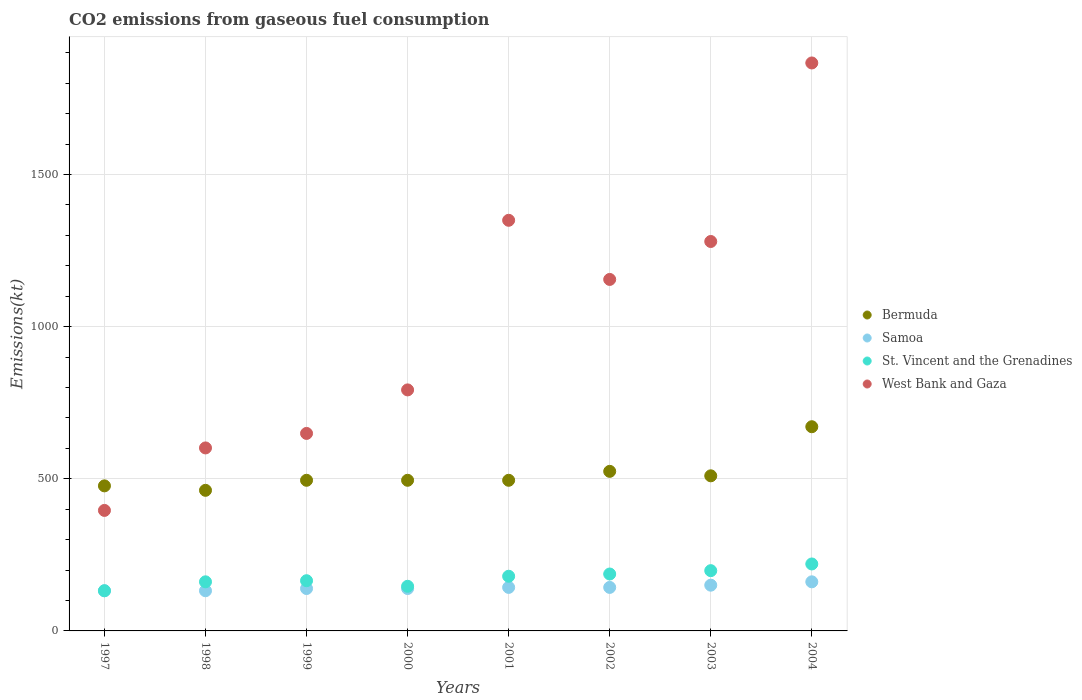How many different coloured dotlines are there?
Keep it short and to the point. 4. What is the amount of CO2 emitted in Bermuda in 1997?
Your answer should be compact. 476.71. Across all years, what is the maximum amount of CO2 emitted in Bermuda?
Your answer should be very brief. 671.06. Across all years, what is the minimum amount of CO2 emitted in Samoa?
Make the answer very short. 132.01. What is the total amount of CO2 emitted in St. Vincent and the Grenadines in the graph?
Ensure brevity in your answer.  1389.79. What is the difference between the amount of CO2 emitted in Bermuda in 1997 and that in 2001?
Make the answer very short. -18.34. What is the difference between the amount of CO2 emitted in Samoa in 2002 and the amount of CO2 emitted in West Bank and Gaza in 1997?
Your answer should be very brief. -253.02. What is the average amount of CO2 emitted in St. Vincent and the Grenadines per year?
Keep it short and to the point. 173.72. In the year 1999, what is the difference between the amount of CO2 emitted in Samoa and amount of CO2 emitted in West Bank and Gaza?
Make the answer very short. -509.71. In how many years, is the amount of CO2 emitted in Bermuda greater than 1600 kt?
Provide a succinct answer. 0. What is the ratio of the amount of CO2 emitted in West Bank and Gaza in 2001 to that in 2003?
Your answer should be very brief. 1.05. Is the amount of CO2 emitted in West Bank and Gaza in 2001 less than that in 2002?
Keep it short and to the point. No. What is the difference between the highest and the second highest amount of CO2 emitted in Samoa?
Offer a terse response. 11. What is the difference between the highest and the lowest amount of CO2 emitted in Samoa?
Provide a short and direct response. 29.34. In how many years, is the amount of CO2 emitted in West Bank and Gaza greater than the average amount of CO2 emitted in West Bank and Gaza taken over all years?
Offer a terse response. 4. Is it the case that in every year, the sum of the amount of CO2 emitted in Bermuda and amount of CO2 emitted in West Bank and Gaza  is greater than the sum of amount of CO2 emitted in Samoa and amount of CO2 emitted in St. Vincent and the Grenadines?
Provide a succinct answer. No. Does the amount of CO2 emitted in West Bank and Gaza monotonically increase over the years?
Make the answer very short. No. Is the amount of CO2 emitted in St. Vincent and the Grenadines strictly less than the amount of CO2 emitted in West Bank and Gaza over the years?
Provide a short and direct response. Yes. How many dotlines are there?
Keep it short and to the point. 4. How many years are there in the graph?
Ensure brevity in your answer.  8. How are the legend labels stacked?
Give a very brief answer. Vertical. What is the title of the graph?
Keep it short and to the point. CO2 emissions from gaseous fuel consumption. What is the label or title of the X-axis?
Your answer should be compact. Years. What is the label or title of the Y-axis?
Ensure brevity in your answer.  Emissions(kt). What is the Emissions(kt) in Bermuda in 1997?
Make the answer very short. 476.71. What is the Emissions(kt) of Samoa in 1997?
Give a very brief answer. 132.01. What is the Emissions(kt) of St. Vincent and the Grenadines in 1997?
Your answer should be very brief. 132.01. What is the Emissions(kt) in West Bank and Gaza in 1997?
Offer a very short reply. 396.04. What is the Emissions(kt) in Bermuda in 1998?
Give a very brief answer. 462.04. What is the Emissions(kt) of Samoa in 1998?
Your answer should be compact. 132.01. What is the Emissions(kt) of St. Vincent and the Grenadines in 1998?
Keep it short and to the point. 161.35. What is the Emissions(kt) of West Bank and Gaza in 1998?
Provide a short and direct response. 601.39. What is the Emissions(kt) of Bermuda in 1999?
Provide a short and direct response. 495.05. What is the Emissions(kt) of Samoa in 1999?
Offer a very short reply. 139.35. What is the Emissions(kt) in St. Vincent and the Grenadines in 1999?
Offer a terse response. 165.01. What is the Emissions(kt) in West Bank and Gaza in 1999?
Offer a terse response. 649.06. What is the Emissions(kt) in Bermuda in 2000?
Ensure brevity in your answer.  495.05. What is the Emissions(kt) of Samoa in 2000?
Your response must be concise. 139.35. What is the Emissions(kt) in St. Vincent and the Grenadines in 2000?
Give a very brief answer. 146.68. What is the Emissions(kt) in West Bank and Gaza in 2000?
Your answer should be compact. 792.07. What is the Emissions(kt) of Bermuda in 2001?
Ensure brevity in your answer.  495.05. What is the Emissions(kt) of Samoa in 2001?
Your answer should be very brief. 143.01. What is the Emissions(kt) of St. Vincent and the Grenadines in 2001?
Keep it short and to the point. 179.68. What is the Emissions(kt) in West Bank and Gaza in 2001?
Ensure brevity in your answer.  1349.46. What is the Emissions(kt) of Bermuda in 2002?
Provide a succinct answer. 524.38. What is the Emissions(kt) of Samoa in 2002?
Provide a succinct answer. 143.01. What is the Emissions(kt) in St. Vincent and the Grenadines in 2002?
Give a very brief answer. 187.02. What is the Emissions(kt) in West Bank and Gaza in 2002?
Make the answer very short. 1155.11. What is the Emissions(kt) in Bermuda in 2003?
Your response must be concise. 509.71. What is the Emissions(kt) of Samoa in 2003?
Offer a terse response. 150.35. What is the Emissions(kt) of St. Vincent and the Grenadines in 2003?
Provide a succinct answer. 198.02. What is the Emissions(kt) of West Bank and Gaza in 2003?
Your answer should be very brief. 1279.78. What is the Emissions(kt) of Bermuda in 2004?
Offer a very short reply. 671.06. What is the Emissions(kt) of Samoa in 2004?
Offer a very short reply. 161.35. What is the Emissions(kt) in St. Vincent and the Grenadines in 2004?
Provide a succinct answer. 220.02. What is the Emissions(kt) of West Bank and Gaza in 2004?
Offer a terse response. 1866.5. Across all years, what is the maximum Emissions(kt) in Bermuda?
Offer a terse response. 671.06. Across all years, what is the maximum Emissions(kt) of Samoa?
Provide a short and direct response. 161.35. Across all years, what is the maximum Emissions(kt) in St. Vincent and the Grenadines?
Ensure brevity in your answer.  220.02. Across all years, what is the maximum Emissions(kt) of West Bank and Gaza?
Offer a terse response. 1866.5. Across all years, what is the minimum Emissions(kt) in Bermuda?
Give a very brief answer. 462.04. Across all years, what is the minimum Emissions(kt) in Samoa?
Your response must be concise. 132.01. Across all years, what is the minimum Emissions(kt) in St. Vincent and the Grenadines?
Your response must be concise. 132.01. Across all years, what is the minimum Emissions(kt) in West Bank and Gaza?
Your answer should be very brief. 396.04. What is the total Emissions(kt) of Bermuda in the graph?
Your answer should be compact. 4129.04. What is the total Emissions(kt) in Samoa in the graph?
Your response must be concise. 1140.44. What is the total Emissions(kt) of St. Vincent and the Grenadines in the graph?
Provide a succinct answer. 1389.79. What is the total Emissions(kt) of West Bank and Gaza in the graph?
Your answer should be compact. 8089.4. What is the difference between the Emissions(kt) in Bermuda in 1997 and that in 1998?
Ensure brevity in your answer.  14.67. What is the difference between the Emissions(kt) of St. Vincent and the Grenadines in 1997 and that in 1998?
Make the answer very short. -29.34. What is the difference between the Emissions(kt) in West Bank and Gaza in 1997 and that in 1998?
Give a very brief answer. -205.35. What is the difference between the Emissions(kt) of Bermuda in 1997 and that in 1999?
Offer a very short reply. -18.34. What is the difference between the Emissions(kt) of Samoa in 1997 and that in 1999?
Offer a very short reply. -7.33. What is the difference between the Emissions(kt) in St. Vincent and the Grenadines in 1997 and that in 1999?
Provide a short and direct response. -33. What is the difference between the Emissions(kt) of West Bank and Gaza in 1997 and that in 1999?
Your answer should be compact. -253.02. What is the difference between the Emissions(kt) in Bermuda in 1997 and that in 2000?
Offer a terse response. -18.34. What is the difference between the Emissions(kt) in Samoa in 1997 and that in 2000?
Offer a very short reply. -7.33. What is the difference between the Emissions(kt) of St. Vincent and the Grenadines in 1997 and that in 2000?
Offer a very short reply. -14.67. What is the difference between the Emissions(kt) in West Bank and Gaza in 1997 and that in 2000?
Provide a succinct answer. -396.04. What is the difference between the Emissions(kt) in Bermuda in 1997 and that in 2001?
Make the answer very short. -18.34. What is the difference between the Emissions(kt) of Samoa in 1997 and that in 2001?
Give a very brief answer. -11. What is the difference between the Emissions(kt) of St. Vincent and the Grenadines in 1997 and that in 2001?
Make the answer very short. -47.67. What is the difference between the Emissions(kt) in West Bank and Gaza in 1997 and that in 2001?
Your answer should be compact. -953.42. What is the difference between the Emissions(kt) of Bermuda in 1997 and that in 2002?
Provide a succinct answer. -47.67. What is the difference between the Emissions(kt) in Samoa in 1997 and that in 2002?
Your answer should be very brief. -11. What is the difference between the Emissions(kt) in St. Vincent and the Grenadines in 1997 and that in 2002?
Provide a succinct answer. -55.01. What is the difference between the Emissions(kt) of West Bank and Gaza in 1997 and that in 2002?
Offer a very short reply. -759.07. What is the difference between the Emissions(kt) of Bermuda in 1997 and that in 2003?
Keep it short and to the point. -33. What is the difference between the Emissions(kt) in Samoa in 1997 and that in 2003?
Make the answer very short. -18.34. What is the difference between the Emissions(kt) in St. Vincent and the Grenadines in 1997 and that in 2003?
Provide a succinct answer. -66.01. What is the difference between the Emissions(kt) of West Bank and Gaza in 1997 and that in 2003?
Give a very brief answer. -883.75. What is the difference between the Emissions(kt) in Bermuda in 1997 and that in 2004?
Keep it short and to the point. -194.35. What is the difference between the Emissions(kt) of Samoa in 1997 and that in 2004?
Your answer should be very brief. -29.34. What is the difference between the Emissions(kt) in St. Vincent and the Grenadines in 1997 and that in 2004?
Keep it short and to the point. -88.01. What is the difference between the Emissions(kt) in West Bank and Gaza in 1997 and that in 2004?
Provide a short and direct response. -1470.47. What is the difference between the Emissions(kt) in Bermuda in 1998 and that in 1999?
Keep it short and to the point. -33. What is the difference between the Emissions(kt) in Samoa in 1998 and that in 1999?
Provide a short and direct response. -7.33. What is the difference between the Emissions(kt) of St. Vincent and the Grenadines in 1998 and that in 1999?
Keep it short and to the point. -3.67. What is the difference between the Emissions(kt) of West Bank and Gaza in 1998 and that in 1999?
Your answer should be very brief. -47.67. What is the difference between the Emissions(kt) in Bermuda in 1998 and that in 2000?
Give a very brief answer. -33. What is the difference between the Emissions(kt) in Samoa in 1998 and that in 2000?
Your response must be concise. -7.33. What is the difference between the Emissions(kt) in St. Vincent and the Grenadines in 1998 and that in 2000?
Offer a terse response. 14.67. What is the difference between the Emissions(kt) in West Bank and Gaza in 1998 and that in 2000?
Make the answer very short. -190.68. What is the difference between the Emissions(kt) of Bermuda in 1998 and that in 2001?
Your answer should be very brief. -33. What is the difference between the Emissions(kt) of Samoa in 1998 and that in 2001?
Ensure brevity in your answer.  -11. What is the difference between the Emissions(kt) of St. Vincent and the Grenadines in 1998 and that in 2001?
Your response must be concise. -18.34. What is the difference between the Emissions(kt) in West Bank and Gaza in 1998 and that in 2001?
Your answer should be very brief. -748.07. What is the difference between the Emissions(kt) of Bermuda in 1998 and that in 2002?
Provide a short and direct response. -62.34. What is the difference between the Emissions(kt) of Samoa in 1998 and that in 2002?
Make the answer very short. -11. What is the difference between the Emissions(kt) in St. Vincent and the Grenadines in 1998 and that in 2002?
Keep it short and to the point. -25.67. What is the difference between the Emissions(kt) in West Bank and Gaza in 1998 and that in 2002?
Your answer should be very brief. -553.72. What is the difference between the Emissions(kt) in Bermuda in 1998 and that in 2003?
Offer a terse response. -47.67. What is the difference between the Emissions(kt) in Samoa in 1998 and that in 2003?
Your answer should be compact. -18.34. What is the difference between the Emissions(kt) in St. Vincent and the Grenadines in 1998 and that in 2003?
Your answer should be very brief. -36.67. What is the difference between the Emissions(kt) of West Bank and Gaza in 1998 and that in 2003?
Your response must be concise. -678.39. What is the difference between the Emissions(kt) in Bermuda in 1998 and that in 2004?
Your response must be concise. -209.02. What is the difference between the Emissions(kt) of Samoa in 1998 and that in 2004?
Make the answer very short. -29.34. What is the difference between the Emissions(kt) of St. Vincent and the Grenadines in 1998 and that in 2004?
Your answer should be very brief. -58.67. What is the difference between the Emissions(kt) in West Bank and Gaza in 1998 and that in 2004?
Your response must be concise. -1265.12. What is the difference between the Emissions(kt) in Samoa in 1999 and that in 2000?
Provide a short and direct response. 0. What is the difference between the Emissions(kt) in St. Vincent and the Grenadines in 1999 and that in 2000?
Provide a short and direct response. 18.34. What is the difference between the Emissions(kt) of West Bank and Gaza in 1999 and that in 2000?
Offer a terse response. -143.01. What is the difference between the Emissions(kt) of Samoa in 1999 and that in 2001?
Make the answer very short. -3.67. What is the difference between the Emissions(kt) in St. Vincent and the Grenadines in 1999 and that in 2001?
Offer a very short reply. -14.67. What is the difference between the Emissions(kt) of West Bank and Gaza in 1999 and that in 2001?
Offer a terse response. -700.4. What is the difference between the Emissions(kt) of Bermuda in 1999 and that in 2002?
Ensure brevity in your answer.  -29.34. What is the difference between the Emissions(kt) of Samoa in 1999 and that in 2002?
Keep it short and to the point. -3.67. What is the difference between the Emissions(kt) of St. Vincent and the Grenadines in 1999 and that in 2002?
Keep it short and to the point. -22. What is the difference between the Emissions(kt) of West Bank and Gaza in 1999 and that in 2002?
Make the answer very short. -506.05. What is the difference between the Emissions(kt) in Bermuda in 1999 and that in 2003?
Offer a very short reply. -14.67. What is the difference between the Emissions(kt) in Samoa in 1999 and that in 2003?
Offer a terse response. -11. What is the difference between the Emissions(kt) of St. Vincent and the Grenadines in 1999 and that in 2003?
Your answer should be compact. -33. What is the difference between the Emissions(kt) in West Bank and Gaza in 1999 and that in 2003?
Provide a succinct answer. -630.72. What is the difference between the Emissions(kt) of Bermuda in 1999 and that in 2004?
Make the answer very short. -176.02. What is the difference between the Emissions(kt) in Samoa in 1999 and that in 2004?
Your response must be concise. -22. What is the difference between the Emissions(kt) of St. Vincent and the Grenadines in 1999 and that in 2004?
Provide a short and direct response. -55.01. What is the difference between the Emissions(kt) in West Bank and Gaza in 1999 and that in 2004?
Offer a terse response. -1217.44. What is the difference between the Emissions(kt) of Samoa in 2000 and that in 2001?
Your response must be concise. -3.67. What is the difference between the Emissions(kt) in St. Vincent and the Grenadines in 2000 and that in 2001?
Keep it short and to the point. -33. What is the difference between the Emissions(kt) of West Bank and Gaza in 2000 and that in 2001?
Keep it short and to the point. -557.38. What is the difference between the Emissions(kt) of Bermuda in 2000 and that in 2002?
Your response must be concise. -29.34. What is the difference between the Emissions(kt) of Samoa in 2000 and that in 2002?
Keep it short and to the point. -3.67. What is the difference between the Emissions(kt) of St. Vincent and the Grenadines in 2000 and that in 2002?
Give a very brief answer. -40.34. What is the difference between the Emissions(kt) in West Bank and Gaza in 2000 and that in 2002?
Give a very brief answer. -363.03. What is the difference between the Emissions(kt) in Bermuda in 2000 and that in 2003?
Offer a terse response. -14.67. What is the difference between the Emissions(kt) in Samoa in 2000 and that in 2003?
Offer a very short reply. -11. What is the difference between the Emissions(kt) in St. Vincent and the Grenadines in 2000 and that in 2003?
Your answer should be compact. -51.34. What is the difference between the Emissions(kt) of West Bank and Gaza in 2000 and that in 2003?
Keep it short and to the point. -487.71. What is the difference between the Emissions(kt) of Bermuda in 2000 and that in 2004?
Keep it short and to the point. -176.02. What is the difference between the Emissions(kt) in Samoa in 2000 and that in 2004?
Provide a succinct answer. -22. What is the difference between the Emissions(kt) of St. Vincent and the Grenadines in 2000 and that in 2004?
Make the answer very short. -73.34. What is the difference between the Emissions(kt) in West Bank and Gaza in 2000 and that in 2004?
Offer a terse response. -1074.43. What is the difference between the Emissions(kt) of Bermuda in 2001 and that in 2002?
Ensure brevity in your answer.  -29.34. What is the difference between the Emissions(kt) in Samoa in 2001 and that in 2002?
Provide a succinct answer. 0. What is the difference between the Emissions(kt) of St. Vincent and the Grenadines in 2001 and that in 2002?
Your response must be concise. -7.33. What is the difference between the Emissions(kt) in West Bank and Gaza in 2001 and that in 2002?
Your response must be concise. 194.35. What is the difference between the Emissions(kt) of Bermuda in 2001 and that in 2003?
Ensure brevity in your answer.  -14.67. What is the difference between the Emissions(kt) in Samoa in 2001 and that in 2003?
Your response must be concise. -7.33. What is the difference between the Emissions(kt) in St. Vincent and the Grenadines in 2001 and that in 2003?
Your answer should be compact. -18.34. What is the difference between the Emissions(kt) of West Bank and Gaza in 2001 and that in 2003?
Give a very brief answer. 69.67. What is the difference between the Emissions(kt) of Bermuda in 2001 and that in 2004?
Your answer should be very brief. -176.02. What is the difference between the Emissions(kt) in Samoa in 2001 and that in 2004?
Provide a short and direct response. -18.34. What is the difference between the Emissions(kt) of St. Vincent and the Grenadines in 2001 and that in 2004?
Offer a very short reply. -40.34. What is the difference between the Emissions(kt) of West Bank and Gaza in 2001 and that in 2004?
Offer a very short reply. -517.05. What is the difference between the Emissions(kt) of Bermuda in 2002 and that in 2003?
Make the answer very short. 14.67. What is the difference between the Emissions(kt) in Samoa in 2002 and that in 2003?
Your response must be concise. -7.33. What is the difference between the Emissions(kt) of St. Vincent and the Grenadines in 2002 and that in 2003?
Offer a terse response. -11. What is the difference between the Emissions(kt) in West Bank and Gaza in 2002 and that in 2003?
Keep it short and to the point. -124.68. What is the difference between the Emissions(kt) of Bermuda in 2002 and that in 2004?
Provide a succinct answer. -146.68. What is the difference between the Emissions(kt) in Samoa in 2002 and that in 2004?
Your response must be concise. -18.34. What is the difference between the Emissions(kt) of St. Vincent and the Grenadines in 2002 and that in 2004?
Your answer should be compact. -33. What is the difference between the Emissions(kt) in West Bank and Gaza in 2002 and that in 2004?
Provide a short and direct response. -711.4. What is the difference between the Emissions(kt) of Bermuda in 2003 and that in 2004?
Keep it short and to the point. -161.35. What is the difference between the Emissions(kt) in Samoa in 2003 and that in 2004?
Keep it short and to the point. -11. What is the difference between the Emissions(kt) in St. Vincent and the Grenadines in 2003 and that in 2004?
Ensure brevity in your answer.  -22. What is the difference between the Emissions(kt) of West Bank and Gaza in 2003 and that in 2004?
Your response must be concise. -586.72. What is the difference between the Emissions(kt) in Bermuda in 1997 and the Emissions(kt) in Samoa in 1998?
Your answer should be very brief. 344.7. What is the difference between the Emissions(kt) in Bermuda in 1997 and the Emissions(kt) in St. Vincent and the Grenadines in 1998?
Provide a succinct answer. 315.36. What is the difference between the Emissions(kt) of Bermuda in 1997 and the Emissions(kt) of West Bank and Gaza in 1998?
Provide a short and direct response. -124.68. What is the difference between the Emissions(kt) of Samoa in 1997 and the Emissions(kt) of St. Vincent and the Grenadines in 1998?
Give a very brief answer. -29.34. What is the difference between the Emissions(kt) in Samoa in 1997 and the Emissions(kt) in West Bank and Gaza in 1998?
Offer a terse response. -469.38. What is the difference between the Emissions(kt) in St. Vincent and the Grenadines in 1997 and the Emissions(kt) in West Bank and Gaza in 1998?
Your response must be concise. -469.38. What is the difference between the Emissions(kt) in Bermuda in 1997 and the Emissions(kt) in Samoa in 1999?
Provide a succinct answer. 337.36. What is the difference between the Emissions(kt) in Bermuda in 1997 and the Emissions(kt) in St. Vincent and the Grenadines in 1999?
Make the answer very short. 311.69. What is the difference between the Emissions(kt) in Bermuda in 1997 and the Emissions(kt) in West Bank and Gaza in 1999?
Offer a very short reply. -172.35. What is the difference between the Emissions(kt) of Samoa in 1997 and the Emissions(kt) of St. Vincent and the Grenadines in 1999?
Provide a succinct answer. -33. What is the difference between the Emissions(kt) in Samoa in 1997 and the Emissions(kt) in West Bank and Gaza in 1999?
Your answer should be very brief. -517.05. What is the difference between the Emissions(kt) of St. Vincent and the Grenadines in 1997 and the Emissions(kt) of West Bank and Gaza in 1999?
Provide a short and direct response. -517.05. What is the difference between the Emissions(kt) in Bermuda in 1997 and the Emissions(kt) in Samoa in 2000?
Your answer should be compact. 337.36. What is the difference between the Emissions(kt) in Bermuda in 1997 and the Emissions(kt) in St. Vincent and the Grenadines in 2000?
Your answer should be very brief. 330.03. What is the difference between the Emissions(kt) in Bermuda in 1997 and the Emissions(kt) in West Bank and Gaza in 2000?
Your response must be concise. -315.36. What is the difference between the Emissions(kt) of Samoa in 1997 and the Emissions(kt) of St. Vincent and the Grenadines in 2000?
Your response must be concise. -14.67. What is the difference between the Emissions(kt) of Samoa in 1997 and the Emissions(kt) of West Bank and Gaza in 2000?
Your answer should be compact. -660.06. What is the difference between the Emissions(kt) of St. Vincent and the Grenadines in 1997 and the Emissions(kt) of West Bank and Gaza in 2000?
Your response must be concise. -660.06. What is the difference between the Emissions(kt) of Bermuda in 1997 and the Emissions(kt) of Samoa in 2001?
Your answer should be compact. 333.7. What is the difference between the Emissions(kt) of Bermuda in 1997 and the Emissions(kt) of St. Vincent and the Grenadines in 2001?
Your response must be concise. 297.03. What is the difference between the Emissions(kt) of Bermuda in 1997 and the Emissions(kt) of West Bank and Gaza in 2001?
Provide a short and direct response. -872.75. What is the difference between the Emissions(kt) of Samoa in 1997 and the Emissions(kt) of St. Vincent and the Grenadines in 2001?
Provide a succinct answer. -47.67. What is the difference between the Emissions(kt) in Samoa in 1997 and the Emissions(kt) in West Bank and Gaza in 2001?
Ensure brevity in your answer.  -1217.44. What is the difference between the Emissions(kt) of St. Vincent and the Grenadines in 1997 and the Emissions(kt) of West Bank and Gaza in 2001?
Give a very brief answer. -1217.44. What is the difference between the Emissions(kt) of Bermuda in 1997 and the Emissions(kt) of Samoa in 2002?
Provide a short and direct response. 333.7. What is the difference between the Emissions(kt) of Bermuda in 1997 and the Emissions(kt) of St. Vincent and the Grenadines in 2002?
Make the answer very short. 289.69. What is the difference between the Emissions(kt) in Bermuda in 1997 and the Emissions(kt) in West Bank and Gaza in 2002?
Your answer should be compact. -678.39. What is the difference between the Emissions(kt) of Samoa in 1997 and the Emissions(kt) of St. Vincent and the Grenadines in 2002?
Provide a short and direct response. -55.01. What is the difference between the Emissions(kt) of Samoa in 1997 and the Emissions(kt) of West Bank and Gaza in 2002?
Your answer should be very brief. -1023.09. What is the difference between the Emissions(kt) of St. Vincent and the Grenadines in 1997 and the Emissions(kt) of West Bank and Gaza in 2002?
Your answer should be very brief. -1023.09. What is the difference between the Emissions(kt) in Bermuda in 1997 and the Emissions(kt) in Samoa in 2003?
Your answer should be very brief. 326.36. What is the difference between the Emissions(kt) in Bermuda in 1997 and the Emissions(kt) in St. Vincent and the Grenadines in 2003?
Your answer should be compact. 278.69. What is the difference between the Emissions(kt) in Bermuda in 1997 and the Emissions(kt) in West Bank and Gaza in 2003?
Your answer should be compact. -803.07. What is the difference between the Emissions(kt) of Samoa in 1997 and the Emissions(kt) of St. Vincent and the Grenadines in 2003?
Offer a very short reply. -66.01. What is the difference between the Emissions(kt) in Samoa in 1997 and the Emissions(kt) in West Bank and Gaza in 2003?
Ensure brevity in your answer.  -1147.77. What is the difference between the Emissions(kt) in St. Vincent and the Grenadines in 1997 and the Emissions(kt) in West Bank and Gaza in 2003?
Ensure brevity in your answer.  -1147.77. What is the difference between the Emissions(kt) of Bermuda in 1997 and the Emissions(kt) of Samoa in 2004?
Make the answer very short. 315.36. What is the difference between the Emissions(kt) in Bermuda in 1997 and the Emissions(kt) in St. Vincent and the Grenadines in 2004?
Your answer should be compact. 256.69. What is the difference between the Emissions(kt) in Bermuda in 1997 and the Emissions(kt) in West Bank and Gaza in 2004?
Provide a short and direct response. -1389.79. What is the difference between the Emissions(kt) of Samoa in 1997 and the Emissions(kt) of St. Vincent and the Grenadines in 2004?
Give a very brief answer. -88.01. What is the difference between the Emissions(kt) of Samoa in 1997 and the Emissions(kt) of West Bank and Gaza in 2004?
Keep it short and to the point. -1734.49. What is the difference between the Emissions(kt) in St. Vincent and the Grenadines in 1997 and the Emissions(kt) in West Bank and Gaza in 2004?
Your answer should be very brief. -1734.49. What is the difference between the Emissions(kt) in Bermuda in 1998 and the Emissions(kt) in Samoa in 1999?
Provide a succinct answer. 322.7. What is the difference between the Emissions(kt) in Bermuda in 1998 and the Emissions(kt) in St. Vincent and the Grenadines in 1999?
Your response must be concise. 297.03. What is the difference between the Emissions(kt) of Bermuda in 1998 and the Emissions(kt) of West Bank and Gaza in 1999?
Keep it short and to the point. -187.02. What is the difference between the Emissions(kt) of Samoa in 1998 and the Emissions(kt) of St. Vincent and the Grenadines in 1999?
Ensure brevity in your answer.  -33. What is the difference between the Emissions(kt) of Samoa in 1998 and the Emissions(kt) of West Bank and Gaza in 1999?
Provide a succinct answer. -517.05. What is the difference between the Emissions(kt) of St. Vincent and the Grenadines in 1998 and the Emissions(kt) of West Bank and Gaza in 1999?
Your response must be concise. -487.71. What is the difference between the Emissions(kt) of Bermuda in 1998 and the Emissions(kt) of Samoa in 2000?
Provide a succinct answer. 322.7. What is the difference between the Emissions(kt) of Bermuda in 1998 and the Emissions(kt) of St. Vincent and the Grenadines in 2000?
Ensure brevity in your answer.  315.36. What is the difference between the Emissions(kt) of Bermuda in 1998 and the Emissions(kt) of West Bank and Gaza in 2000?
Make the answer very short. -330.03. What is the difference between the Emissions(kt) in Samoa in 1998 and the Emissions(kt) in St. Vincent and the Grenadines in 2000?
Your answer should be very brief. -14.67. What is the difference between the Emissions(kt) of Samoa in 1998 and the Emissions(kt) of West Bank and Gaza in 2000?
Provide a short and direct response. -660.06. What is the difference between the Emissions(kt) of St. Vincent and the Grenadines in 1998 and the Emissions(kt) of West Bank and Gaza in 2000?
Make the answer very short. -630.72. What is the difference between the Emissions(kt) in Bermuda in 1998 and the Emissions(kt) in Samoa in 2001?
Ensure brevity in your answer.  319.03. What is the difference between the Emissions(kt) in Bermuda in 1998 and the Emissions(kt) in St. Vincent and the Grenadines in 2001?
Your answer should be compact. 282.36. What is the difference between the Emissions(kt) in Bermuda in 1998 and the Emissions(kt) in West Bank and Gaza in 2001?
Ensure brevity in your answer.  -887.41. What is the difference between the Emissions(kt) in Samoa in 1998 and the Emissions(kt) in St. Vincent and the Grenadines in 2001?
Provide a succinct answer. -47.67. What is the difference between the Emissions(kt) of Samoa in 1998 and the Emissions(kt) of West Bank and Gaza in 2001?
Make the answer very short. -1217.44. What is the difference between the Emissions(kt) in St. Vincent and the Grenadines in 1998 and the Emissions(kt) in West Bank and Gaza in 2001?
Provide a short and direct response. -1188.11. What is the difference between the Emissions(kt) of Bermuda in 1998 and the Emissions(kt) of Samoa in 2002?
Ensure brevity in your answer.  319.03. What is the difference between the Emissions(kt) in Bermuda in 1998 and the Emissions(kt) in St. Vincent and the Grenadines in 2002?
Offer a terse response. 275.02. What is the difference between the Emissions(kt) of Bermuda in 1998 and the Emissions(kt) of West Bank and Gaza in 2002?
Your answer should be very brief. -693.06. What is the difference between the Emissions(kt) of Samoa in 1998 and the Emissions(kt) of St. Vincent and the Grenadines in 2002?
Keep it short and to the point. -55.01. What is the difference between the Emissions(kt) in Samoa in 1998 and the Emissions(kt) in West Bank and Gaza in 2002?
Provide a short and direct response. -1023.09. What is the difference between the Emissions(kt) in St. Vincent and the Grenadines in 1998 and the Emissions(kt) in West Bank and Gaza in 2002?
Provide a succinct answer. -993.76. What is the difference between the Emissions(kt) in Bermuda in 1998 and the Emissions(kt) in Samoa in 2003?
Provide a short and direct response. 311.69. What is the difference between the Emissions(kt) in Bermuda in 1998 and the Emissions(kt) in St. Vincent and the Grenadines in 2003?
Ensure brevity in your answer.  264.02. What is the difference between the Emissions(kt) in Bermuda in 1998 and the Emissions(kt) in West Bank and Gaza in 2003?
Provide a succinct answer. -817.74. What is the difference between the Emissions(kt) in Samoa in 1998 and the Emissions(kt) in St. Vincent and the Grenadines in 2003?
Offer a terse response. -66.01. What is the difference between the Emissions(kt) in Samoa in 1998 and the Emissions(kt) in West Bank and Gaza in 2003?
Make the answer very short. -1147.77. What is the difference between the Emissions(kt) of St. Vincent and the Grenadines in 1998 and the Emissions(kt) of West Bank and Gaza in 2003?
Make the answer very short. -1118.43. What is the difference between the Emissions(kt) in Bermuda in 1998 and the Emissions(kt) in Samoa in 2004?
Your answer should be compact. 300.69. What is the difference between the Emissions(kt) of Bermuda in 1998 and the Emissions(kt) of St. Vincent and the Grenadines in 2004?
Provide a short and direct response. 242.02. What is the difference between the Emissions(kt) of Bermuda in 1998 and the Emissions(kt) of West Bank and Gaza in 2004?
Ensure brevity in your answer.  -1404.46. What is the difference between the Emissions(kt) of Samoa in 1998 and the Emissions(kt) of St. Vincent and the Grenadines in 2004?
Provide a short and direct response. -88.01. What is the difference between the Emissions(kt) of Samoa in 1998 and the Emissions(kt) of West Bank and Gaza in 2004?
Offer a very short reply. -1734.49. What is the difference between the Emissions(kt) in St. Vincent and the Grenadines in 1998 and the Emissions(kt) in West Bank and Gaza in 2004?
Provide a succinct answer. -1705.15. What is the difference between the Emissions(kt) of Bermuda in 1999 and the Emissions(kt) of Samoa in 2000?
Provide a short and direct response. 355.7. What is the difference between the Emissions(kt) of Bermuda in 1999 and the Emissions(kt) of St. Vincent and the Grenadines in 2000?
Your response must be concise. 348.37. What is the difference between the Emissions(kt) of Bermuda in 1999 and the Emissions(kt) of West Bank and Gaza in 2000?
Offer a very short reply. -297.03. What is the difference between the Emissions(kt) in Samoa in 1999 and the Emissions(kt) in St. Vincent and the Grenadines in 2000?
Make the answer very short. -7.33. What is the difference between the Emissions(kt) of Samoa in 1999 and the Emissions(kt) of West Bank and Gaza in 2000?
Keep it short and to the point. -652.73. What is the difference between the Emissions(kt) of St. Vincent and the Grenadines in 1999 and the Emissions(kt) of West Bank and Gaza in 2000?
Give a very brief answer. -627.06. What is the difference between the Emissions(kt) in Bermuda in 1999 and the Emissions(kt) in Samoa in 2001?
Your answer should be very brief. 352.03. What is the difference between the Emissions(kt) in Bermuda in 1999 and the Emissions(kt) in St. Vincent and the Grenadines in 2001?
Offer a very short reply. 315.36. What is the difference between the Emissions(kt) of Bermuda in 1999 and the Emissions(kt) of West Bank and Gaza in 2001?
Give a very brief answer. -854.41. What is the difference between the Emissions(kt) in Samoa in 1999 and the Emissions(kt) in St. Vincent and the Grenadines in 2001?
Provide a short and direct response. -40.34. What is the difference between the Emissions(kt) of Samoa in 1999 and the Emissions(kt) of West Bank and Gaza in 2001?
Make the answer very short. -1210.11. What is the difference between the Emissions(kt) in St. Vincent and the Grenadines in 1999 and the Emissions(kt) in West Bank and Gaza in 2001?
Offer a terse response. -1184.44. What is the difference between the Emissions(kt) of Bermuda in 1999 and the Emissions(kt) of Samoa in 2002?
Your answer should be compact. 352.03. What is the difference between the Emissions(kt) in Bermuda in 1999 and the Emissions(kt) in St. Vincent and the Grenadines in 2002?
Offer a terse response. 308.03. What is the difference between the Emissions(kt) in Bermuda in 1999 and the Emissions(kt) in West Bank and Gaza in 2002?
Ensure brevity in your answer.  -660.06. What is the difference between the Emissions(kt) of Samoa in 1999 and the Emissions(kt) of St. Vincent and the Grenadines in 2002?
Your answer should be compact. -47.67. What is the difference between the Emissions(kt) in Samoa in 1999 and the Emissions(kt) in West Bank and Gaza in 2002?
Provide a short and direct response. -1015.76. What is the difference between the Emissions(kt) in St. Vincent and the Grenadines in 1999 and the Emissions(kt) in West Bank and Gaza in 2002?
Your answer should be compact. -990.09. What is the difference between the Emissions(kt) of Bermuda in 1999 and the Emissions(kt) of Samoa in 2003?
Your answer should be compact. 344.7. What is the difference between the Emissions(kt) of Bermuda in 1999 and the Emissions(kt) of St. Vincent and the Grenadines in 2003?
Offer a terse response. 297.03. What is the difference between the Emissions(kt) of Bermuda in 1999 and the Emissions(kt) of West Bank and Gaza in 2003?
Provide a succinct answer. -784.74. What is the difference between the Emissions(kt) of Samoa in 1999 and the Emissions(kt) of St. Vincent and the Grenadines in 2003?
Keep it short and to the point. -58.67. What is the difference between the Emissions(kt) in Samoa in 1999 and the Emissions(kt) in West Bank and Gaza in 2003?
Keep it short and to the point. -1140.44. What is the difference between the Emissions(kt) of St. Vincent and the Grenadines in 1999 and the Emissions(kt) of West Bank and Gaza in 2003?
Offer a very short reply. -1114.77. What is the difference between the Emissions(kt) of Bermuda in 1999 and the Emissions(kt) of Samoa in 2004?
Give a very brief answer. 333.7. What is the difference between the Emissions(kt) of Bermuda in 1999 and the Emissions(kt) of St. Vincent and the Grenadines in 2004?
Offer a very short reply. 275.02. What is the difference between the Emissions(kt) in Bermuda in 1999 and the Emissions(kt) in West Bank and Gaza in 2004?
Make the answer very short. -1371.46. What is the difference between the Emissions(kt) of Samoa in 1999 and the Emissions(kt) of St. Vincent and the Grenadines in 2004?
Offer a very short reply. -80.67. What is the difference between the Emissions(kt) in Samoa in 1999 and the Emissions(kt) in West Bank and Gaza in 2004?
Your answer should be compact. -1727.16. What is the difference between the Emissions(kt) of St. Vincent and the Grenadines in 1999 and the Emissions(kt) of West Bank and Gaza in 2004?
Give a very brief answer. -1701.49. What is the difference between the Emissions(kt) of Bermuda in 2000 and the Emissions(kt) of Samoa in 2001?
Provide a succinct answer. 352.03. What is the difference between the Emissions(kt) in Bermuda in 2000 and the Emissions(kt) in St. Vincent and the Grenadines in 2001?
Offer a terse response. 315.36. What is the difference between the Emissions(kt) in Bermuda in 2000 and the Emissions(kt) in West Bank and Gaza in 2001?
Your answer should be compact. -854.41. What is the difference between the Emissions(kt) in Samoa in 2000 and the Emissions(kt) in St. Vincent and the Grenadines in 2001?
Offer a very short reply. -40.34. What is the difference between the Emissions(kt) of Samoa in 2000 and the Emissions(kt) of West Bank and Gaza in 2001?
Provide a short and direct response. -1210.11. What is the difference between the Emissions(kt) of St. Vincent and the Grenadines in 2000 and the Emissions(kt) of West Bank and Gaza in 2001?
Make the answer very short. -1202.78. What is the difference between the Emissions(kt) of Bermuda in 2000 and the Emissions(kt) of Samoa in 2002?
Keep it short and to the point. 352.03. What is the difference between the Emissions(kt) in Bermuda in 2000 and the Emissions(kt) in St. Vincent and the Grenadines in 2002?
Keep it short and to the point. 308.03. What is the difference between the Emissions(kt) in Bermuda in 2000 and the Emissions(kt) in West Bank and Gaza in 2002?
Provide a short and direct response. -660.06. What is the difference between the Emissions(kt) in Samoa in 2000 and the Emissions(kt) in St. Vincent and the Grenadines in 2002?
Ensure brevity in your answer.  -47.67. What is the difference between the Emissions(kt) in Samoa in 2000 and the Emissions(kt) in West Bank and Gaza in 2002?
Give a very brief answer. -1015.76. What is the difference between the Emissions(kt) in St. Vincent and the Grenadines in 2000 and the Emissions(kt) in West Bank and Gaza in 2002?
Provide a short and direct response. -1008.42. What is the difference between the Emissions(kt) of Bermuda in 2000 and the Emissions(kt) of Samoa in 2003?
Give a very brief answer. 344.7. What is the difference between the Emissions(kt) in Bermuda in 2000 and the Emissions(kt) in St. Vincent and the Grenadines in 2003?
Your answer should be compact. 297.03. What is the difference between the Emissions(kt) in Bermuda in 2000 and the Emissions(kt) in West Bank and Gaza in 2003?
Keep it short and to the point. -784.74. What is the difference between the Emissions(kt) of Samoa in 2000 and the Emissions(kt) of St. Vincent and the Grenadines in 2003?
Keep it short and to the point. -58.67. What is the difference between the Emissions(kt) in Samoa in 2000 and the Emissions(kt) in West Bank and Gaza in 2003?
Ensure brevity in your answer.  -1140.44. What is the difference between the Emissions(kt) of St. Vincent and the Grenadines in 2000 and the Emissions(kt) of West Bank and Gaza in 2003?
Your answer should be very brief. -1133.1. What is the difference between the Emissions(kt) of Bermuda in 2000 and the Emissions(kt) of Samoa in 2004?
Provide a short and direct response. 333.7. What is the difference between the Emissions(kt) in Bermuda in 2000 and the Emissions(kt) in St. Vincent and the Grenadines in 2004?
Offer a terse response. 275.02. What is the difference between the Emissions(kt) of Bermuda in 2000 and the Emissions(kt) of West Bank and Gaza in 2004?
Offer a terse response. -1371.46. What is the difference between the Emissions(kt) of Samoa in 2000 and the Emissions(kt) of St. Vincent and the Grenadines in 2004?
Ensure brevity in your answer.  -80.67. What is the difference between the Emissions(kt) in Samoa in 2000 and the Emissions(kt) in West Bank and Gaza in 2004?
Your answer should be very brief. -1727.16. What is the difference between the Emissions(kt) of St. Vincent and the Grenadines in 2000 and the Emissions(kt) of West Bank and Gaza in 2004?
Ensure brevity in your answer.  -1719.82. What is the difference between the Emissions(kt) in Bermuda in 2001 and the Emissions(kt) in Samoa in 2002?
Provide a short and direct response. 352.03. What is the difference between the Emissions(kt) in Bermuda in 2001 and the Emissions(kt) in St. Vincent and the Grenadines in 2002?
Your response must be concise. 308.03. What is the difference between the Emissions(kt) of Bermuda in 2001 and the Emissions(kt) of West Bank and Gaza in 2002?
Offer a very short reply. -660.06. What is the difference between the Emissions(kt) in Samoa in 2001 and the Emissions(kt) in St. Vincent and the Grenadines in 2002?
Offer a very short reply. -44. What is the difference between the Emissions(kt) in Samoa in 2001 and the Emissions(kt) in West Bank and Gaza in 2002?
Your response must be concise. -1012.09. What is the difference between the Emissions(kt) in St. Vincent and the Grenadines in 2001 and the Emissions(kt) in West Bank and Gaza in 2002?
Your answer should be very brief. -975.42. What is the difference between the Emissions(kt) of Bermuda in 2001 and the Emissions(kt) of Samoa in 2003?
Your response must be concise. 344.7. What is the difference between the Emissions(kt) in Bermuda in 2001 and the Emissions(kt) in St. Vincent and the Grenadines in 2003?
Offer a very short reply. 297.03. What is the difference between the Emissions(kt) of Bermuda in 2001 and the Emissions(kt) of West Bank and Gaza in 2003?
Your answer should be very brief. -784.74. What is the difference between the Emissions(kt) in Samoa in 2001 and the Emissions(kt) in St. Vincent and the Grenadines in 2003?
Provide a succinct answer. -55.01. What is the difference between the Emissions(kt) in Samoa in 2001 and the Emissions(kt) in West Bank and Gaza in 2003?
Make the answer very short. -1136.77. What is the difference between the Emissions(kt) of St. Vincent and the Grenadines in 2001 and the Emissions(kt) of West Bank and Gaza in 2003?
Your response must be concise. -1100.1. What is the difference between the Emissions(kt) of Bermuda in 2001 and the Emissions(kt) of Samoa in 2004?
Give a very brief answer. 333.7. What is the difference between the Emissions(kt) of Bermuda in 2001 and the Emissions(kt) of St. Vincent and the Grenadines in 2004?
Your response must be concise. 275.02. What is the difference between the Emissions(kt) in Bermuda in 2001 and the Emissions(kt) in West Bank and Gaza in 2004?
Ensure brevity in your answer.  -1371.46. What is the difference between the Emissions(kt) of Samoa in 2001 and the Emissions(kt) of St. Vincent and the Grenadines in 2004?
Make the answer very short. -77.01. What is the difference between the Emissions(kt) of Samoa in 2001 and the Emissions(kt) of West Bank and Gaza in 2004?
Ensure brevity in your answer.  -1723.49. What is the difference between the Emissions(kt) of St. Vincent and the Grenadines in 2001 and the Emissions(kt) of West Bank and Gaza in 2004?
Provide a short and direct response. -1686.82. What is the difference between the Emissions(kt) of Bermuda in 2002 and the Emissions(kt) of Samoa in 2003?
Your answer should be very brief. 374.03. What is the difference between the Emissions(kt) of Bermuda in 2002 and the Emissions(kt) of St. Vincent and the Grenadines in 2003?
Provide a short and direct response. 326.36. What is the difference between the Emissions(kt) of Bermuda in 2002 and the Emissions(kt) of West Bank and Gaza in 2003?
Provide a short and direct response. -755.4. What is the difference between the Emissions(kt) of Samoa in 2002 and the Emissions(kt) of St. Vincent and the Grenadines in 2003?
Provide a short and direct response. -55.01. What is the difference between the Emissions(kt) in Samoa in 2002 and the Emissions(kt) in West Bank and Gaza in 2003?
Your answer should be very brief. -1136.77. What is the difference between the Emissions(kt) in St. Vincent and the Grenadines in 2002 and the Emissions(kt) in West Bank and Gaza in 2003?
Provide a short and direct response. -1092.77. What is the difference between the Emissions(kt) in Bermuda in 2002 and the Emissions(kt) in Samoa in 2004?
Make the answer very short. 363.03. What is the difference between the Emissions(kt) of Bermuda in 2002 and the Emissions(kt) of St. Vincent and the Grenadines in 2004?
Your answer should be very brief. 304.36. What is the difference between the Emissions(kt) in Bermuda in 2002 and the Emissions(kt) in West Bank and Gaza in 2004?
Your answer should be compact. -1342.12. What is the difference between the Emissions(kt) of Samoa in 2002 and the Emissions(kt) of St. Vincent and the Grenadines in 2004?
Your answer should be very brief. -77.01. What is the difference between the Emissions(kt) in Samoa in 2002 and the Emissions(kt) in West Bank and Gaza in 2004?
Give a very brief answer. -1723.49. What is the difference between the Emissions(kt) of St. Vincent and the Grenadines in 2002 and the Emissions(kt) of West Bank and Gaza in 2004?
Your answer should be very brief. -1679.49. What is the difference between the Emissions(kt) of Bermuda in 2003 and the Emissions(kt) of Samoa in 2004?
Provide a short and direct response. 348.37. What is the difference between the Emissions(kt) of Bermuda in 2003 and the Emissions(kt) of St. Vincent and the Grenadines in 2004?
Offer a terse response. 289.69. What is the difference between the Emissions(kt) in Bermuda in 2003 and the Emissions(kt) in West Bank and Gaza in 2004?
Provide a short and direct response. -1356.79. What is the difference between the Emissions(kt) of Samoa in 2003 and the Emissions(kt) of St. Vincent and the Grenadines in 2004?
Make the answer very short. -69.67. What is the difference between the Emissions(kt) in Samoa in 2003 and the Emissions(kt) in West Bank and Gaza in 2004?
Your response must be concise. -1716.16. What is the difference between the Emissions(kt) in St. Vincent and the Grenadines in 2003 and the Emissions(kt) in West Bank and Gaza in 2004?
Offer a terse response. -1668.48. What is the average Emissions(kt) in Bermuda per year?
Provide a succinct answer. 516.13. What is the average Emissions(kt) in Samoa per year?
Make the answer very short. 142.55. What is the average Emissions(kt) of St. Vincent and the Grenadines per year?
Your answer should be compact. 173.72. What is the average Emissions(kt) in West Bank and Gaza per year?
Offer a terse response. 1011.18. In the year 1997, what is the difference between the Emissions(kt) in Bermuda and Emissions(kt) in Samoa?
Your answer should be compact. 344.7. In the year 1997, what is the difference between the Emissions(kt) in Bermuda and Emissions(kt) in St. Vincent and the Grenadines?
Give a very brief answer. 344.7. In the year 1997, what is the difference between the Emissions(kt) in Bermuda and Emissions(kt) in West Bank and Gaza?
Offer a terse response. 80.67. In the year 1997, what is the difference between the Emissions(kt) of Samoa and Emissions(kt) of St. Vincent and the Grenadines?
Offer a very short reply. 0. In the year 1997, what is the difference between the Emissions(kt) in Samoa and Emissions(kt) in West Bank and Gaza?
Offer a terse response. -264.02. In the year 1997, what is the difference between the Emissions(kt) in St. Vincent and the Grenadines and Emissions(kt) in West Bank and Gaza?
Provide a succinct answer. -264.02. In the year 1998, what is the difference between the Emissions(kt) of Bermuda and Emissions(kt) of Samoa?
Keep it short and to the point. 330.03. In the year 1998, what is the difference between the Emissions(kt) in Bermuda and Emissions(kt) in St. Vincent and the Grenadines?
Ensure brevity in your answer.  300.69. In the year 1998, what is the difference between the Emissions(kt) of Bermuda and Emissions(kt) of West Bank and Gaza?
Offer a terse response. -139.35. In the year 1998, what is the difference between the Emissions(kt) of Samoa and Emissions(kt) of St. Vincent and the Grenadines?
Ensure brevity in your answer.  -29.34. In the year 1998, what is the difference between the Emissions(kt) in Samoa and Emissions(kt) in West Bank and Gaza?
Your answer should be compact. -469.38. In the year 1998, what is the difference between the Emissions(kt) in St. Vincent and the Grenadines and Emissions(kt) in West Bank and Gaza?
Make the answer very short. -440.04. In the year 1999, what is the difference between the Emissions(kt) of Bermuda and Emissions(kt) of Samoa?
Give a very brief answer. 355.7. In the year 1999, what is the difference between the Emissions(kt) in Bermuda and Emissions(kt) in St. Vincent and the Grenadines?
Provide a succinct answer. 330.03. In the year 1999, what is the difference between the Emissions(kt) of Bermuda and Emissions(kt) of West Bank and Gaza?
Make the answer very short. -154.01. In the year 1999, what is the difference between the Emissions(kt) in Samoa and Emissions(kt) in St. Vincent and the Grenadines?
Your response must be concise. -25.67. In the year 1999, what is the difference between the Emissions(kt) in Samoa and Emissions(kt) in West Bank and Gaza?
Offer a very short reply. -509.71. In the year 1999, what is the difference between the Emissions(kt) of St. Vincent and the Grenadines and Emissions(kt) of West Bank and Gaza?
Your answer should be compact. -484.04. In the year 2000, what is the difference between the Emissions(kt) in Bermuda and Emissions(kt) in Samoa?
Keep it short and to the point. 355.7. In the year 2000, what is the difference between the Emissions(kt) of Bermuda and Emissions(kt) of St. Vincent and the Grenadines?
Offer a terse response. 348.37. In the year 2000, what is the difference between the Emissions(kt) of Bermuda and Emissions(kt) of West Bank and Gaza?
Make the answer very short. -297.03. In the year 2000, what is the difference between the Emissions(kt) of Samoa and Emissions(kt) of St. Vincent and the Grenadines?
Make the answer very short. -7.33. In the year 2000, what is the difference between the Emissions(kt) in Samoa and Emissions(kt) in West Bank and Gaza?
Your response must be concise. -652.73. In the year 2000, what is the difference between the Emissions(kt) in St. Vincent and the Grenadines and Emissions(kt) in West Bank and Gaza?
Offer a terse response. -645.39. In the year 2001, what is the difference between the Emissions(kt) of Bermuda and Emissions(kt) of Samoa?
Your answer should be compact. 352.03. In the year 2001, what is the difference between the Emissions(kt) in Bermuda and Emissions(kt) in St. Vincent and the Grenadines?
Offer a very short reply. 315.36. In the year 2001, what is the difference between the Emissions(kt) of Bermuda and Emissions(kt) of West Bank and Gaza?
Keep it short and to the point. -854.41. In the year 2001, what is the difference between the Emissions(kt) in Samoa and Emissions(kt) in St. Vincent and the Grenadines?
Offer a very short reply. -36.67. In the year 2001, what is the difference between the Emissions(kt) of Samoa and Emissions(kt) of West Bank and Gaza?
Give a very brief answer. -1206.44. In the year 2001, what is the difference between the Emissions(kt) of St. Vincent and the Grenadines and Emissions(kt) of West Bank and Gaza?
Give a very brief answer. -1169.77. In the year 2002, what is the difference between the Emissions(kt) in Bermuda and Emissions(kt) in Samoa?
Offer a terse response. 381.37. In the year 2002, what is the difference between the Emissions(kt) of Bermuda and Emissions(kt) of St. Vincent and the Grenadines?
Your response must be concise. 337.36. In the year 2002, what is the difference between the Emissions(kt) of Bermuda and Emissions(kt) of West Bank and Gaza?
Offer a very short reply. -630.72. In the year 2002, what is the difference between the Emissions(kt) in Samoa and Emissions(kt) in St. Vincent and the Grenadines?
Give a very brief answer. -44. In the year 2002, what is the difference between the Emissions(kt) of Samoa and Emissions(kt) of West Bank and Gaza?
Ensure brevity in your answer.  -1012.09. In the year 2002, what is the difference between the Emissions(kt) of St. Vincent and the Grenadines and Emissions(kt) of West Bank and Gaza?
Provide a short and direct response. -968.09. In the year 2003, what is the difference between the Emissions(kt) in Bermuda and Emissions(kt) in Samoa?
Your answer should be compact. 359.37. In the year 2003, what is the difference between the Emissions(kt) in Bermuda and Emissions(kt) in St. Vincent and the Grenadines?
Offer a very short reply. 311.69. In the year 2003, what is the difference between the Emissions(kt) in Bermuda and Emissions(kt) in West Bank and Gaza?
Provide a short and direct response. -770.07. In the year 2003, what is the difference between the Emissions(kt) of Samoa and Emissions(kt) of St. Vincent and the Grenadines?
Make the answer very short. -47.67. In the year 2003, what is the difference between the Emissions(kt) of Samoa and Emissions(kt) of West Bank and Gaza?
Your answer should be very brief. -1129.44. In the year 2003, what is the difference between the Emissions(kt) of St. Vincent and the Grenadines and Emissions(kt) of West Bank and Gaza?
Give a very brief answer. -1081.77. In the year 2004, what is the difference between the Emissions(kt) of Bermuda and Emissions(kt) of Samoa?
Your answer should be compact. 509.71. In the year 2004, what is the difference between the Emissions(kt) of Bermuda and Emissions(kt) of St. Vincent and the Grenadines?
Make the answer very short. 451.04. In the year 2004, what is the difference between the Emissions(kt) of Bermuda and Emissions(kt) of West Bank and Gaza?
Offer a very short reply. -1195.44. In the year 2004, what is the difference between the Emissions(kt) in Samoa and Emissions(kt) in St. Vincent and the Grenadines?
Offer a terse response. -58.67. In the year 2004, what is the difference between the Emissions(kt) of Samoa and Emissions(kt) of West Bank and Gaza?
Your answer should be compact. -1705.15. In the year 2004, what is the difference between the Emissions(kt) in St. Vincent and the Grenadines and Emissions(kt) in West Bank and Gaza?
Keep it short and to the point. -1646.48. What is the ratio of the Emissions(kt) of Bermuda in 1997 to that in 1998?
Provide a succinct answer. 1.03. What is the ratio of the Emissions(kt) in St. Vincent and the Grenadines in 1997 to that in 1998?
Keep it short and to the point. 0.82. What is the ratio of the Emissions(kt) in West Bank and Gaza in 1997 to that in 1998?
Your answer should be compact. 0.66. What is the ratio of the Emissions(kt) of Samoa in 1997 to that in 1999?
Offer a terse response. 0.95. What is the ratio of the Emissions(kt) of West Bank and Gaza in 1997 to that in 1999?
Keep it short and to the point. 0.61. What is the ratio of the Emissions(kt) in Samoa in 1997 to that in 2000?
Provide a succinct answer. 0.95. What is the ratio of the Emissions(kt) of West Bank and Gaza in 1997 to that in 2000?
Ensure brevity in your answer.  0.5. What is the ratio of the Emissions(kt) of Samoa in 1997 to that in 2001?
Keep it short and to the point. 0.92. What is the ratio of the Emissions(kt) of St. Vincent and the Grenadines in 1997 to that in 2001?
Your response must be concise. 0.73. What is the ratio of the Emissions(kt) in West Bank and Gaza in 1997 to that in 2001?
Your answer should be very brief. 0.29. What is the ratio of the Emissions(kt) of Bermuda in 1997 to that in 2002?
Keep it short and to the point. 0.91. What is the ratio of the Emissions(kt) in Samoa in 1997 to that in 2002?
Offer a very short reply. 0.92. What is the ratio of the Emissions(kt) of St. Vincent and the Grenadines in 1997 to that in 2002?
Your response must be concise. 0.71. What is the ratio of the Emissions(kt) in West Bank and Gaza in 1997 to that in 2002?
Make the answer very short. 0.34. What is the ratio of the Emissions(kt) in Bermuda in 1997 to that in 2003?
Your answer should be compact. 0.94. What is the ratio of the Emissions(kt) of Samoa in 1997 to that in 2003?
Make the answer very short. 0.88. What is the ratio of the Emissions(kt) in St. Vincent and the Grenadines in 1997 to that in 2003?
Your answer should be compact. 0.67. What is the ratio of the Emissions(kt) in West Bank and Gaza in 1997 to that in 2003?
Keep it short and to the point. 0.31. What is the ratio of the Emissions(kt) of Bermuda in 1997 to that in 2004?
Your response must be concise. 0.71. What is the ratio of the Emissions(kt) of Samoa in 1997 to that in 2004?
Provide a succinct answer. 0.82. What is the ratio of the Emissions(kt) in West Bank and Gaza in 1997 to that in 2004?
Your answer should be compact. 0.21. What is the ratio of the Emissions(kt) in St. Vincent and the Grenadines in 1998 to that in 1999?
Offer a terse response. 0.98. What is the ratio of the Emissions(kt) of West Bank and Gaza in 1998 to that in 1999?
Make the answer very short. 0.93. What is the ratio of the Emissions(kt) of Bermuda in 1998 to that in 2000?
Provide a short and direct response. 0.93. What is the ratio of the Emissions(kt) of Samoa in 1998 to that in 2000?
Ensure brevity in your answer.  0.95. What is the ratio of the Emissions(kt) of West Bank and Gaza in 1998 to that in 2000?
Provide a succinct answer. 0.76. What is the ratio of the Emissions(kt) in Bermuda in 1998 to that in 2001?
Offer a terse response. 0.93. What is the ratio of the Emissions(kt) in Samoa in 1998 to that in 2001?
Offer a terse response. 0.92. What is the ratio of the Emissions(kt) in St. Vincent and the Grenadines in 1998 to that in 2001?
Provide a short and direct response. 0.9. What is the ratio of the Emissions(kt) in West Bank and Gaza in 1998 to that in 2001?
Offer a very short reply. 0.45. What is the ratio of the Emissions(kt) in Bermuda in 1998 to that in 2002?
Give a very brief answer. 0.88. What is the ratio of the Emissions(kt) of St. Vincent and the Grenadines in 1998 to that in 2002?
Your response must be concise. 0.86. What is the ratio of the Emissions(kt) in West Bank and Gaza in 1998 to that in 2002?
Ensure brevity in your answer.  0.52. What is the ratio of the Emissions(kt) of Bermuda in 1998 to that in 2003?
Ensure brevity in your answer.  0.91. What is the ratio of the Emissions(kt) in Samoa in 1998 to that in 2003?
Keep it short and to the point. 0.88. What is the ratio of the Emissions(kt) in St. Vincent and the Grenadines in 1998 to that in 2003?
Keep it short and to the point. 0.81. What is the ratio of the Emissions(kt) in West Bank and Gaza in 1998 to that in 2003?
Offer a very short reply. 0.47. What is the ratio of the Emissions(kt) of Bermuda in 1998 to that in 2004?
Make the answer very short. 0.69. What is the ratio of the Emissions(kt) in Samoa in 1998 to that in 2004?
Offer a very short reply. 0.82. What is the ratio of the Emissions(kt) in St. Vincent and the Grenadines in 1998 to that in 2004?
Give a very brief answer. 0.73. What is the ratio of the Emissions(kt) in West Bank and Gaza in 1998 to that in 2004?
Offer a terse response. 0.32. What is the ratio of the Emissions(kt) in Bermuda in 1999 to that in 2000?
Give a very brief answer. 1. What is the ratio of the Emissions(kt) in St. Vincent and the Grenadines in 1999 to that in 2000?
Ensure brevity in your answer.  1.12. What is the ratio of the Emissions(kt) of West Bank and Gaza in 1999 to that in 2000?
Provide a short and direct response. 0.82. What is the ratio of the Emissions(kt) of Bermuda in 1999 to that in 2001?
Make the answer very short. 1. What is the ratio of the Emissions(kt) in Samoa in 1999 to that in 2001?
Offer a terse response. 0.97. What is the ratio of the Emissions(kt) of St. Vincent and the Grenadines in 1999 to that in 2001?
Offer a terse response. 0.92. What is the ratio of the Emissions(kt) of West Bank and Gaza in 1999 to that in 2001?
Offer a very short reply. 0.48. What is the ratio of the Emissions(kt) of Bermuda in 1999 to that in 2002?
Provide a succinct answer. 0.94. What is the ratio of the Emissions(kt) of Samoa in 1999 to that in 2002?
Your response must be concise. 0.97. What is the ratio of the Emissions(kt) in St. Vincent and the Grenadines in 1999 to that in 2002?
Offer a very short reply. 0.88. What is the ratio of the Emissions(kt) in West Bank and Gaza in 1999 to that in 2002?
Your answer should be very brief. 0.56. What is the ratio of the Emissions(kt) of Bermuda in 1999 to that in 2003?
Your response must be concise. 0.97. What is the ratio of the Emissions(kt) of Samoa in 1999 to that in 2003?
Ensure brevity in your answer.  0.93. What is the ratio of the Emissions(kt) in St. Vincent and the Grenadines in 1999 to that in 2003?
Your answer should be very brief. 0.83. What is the ratio of the Emissions(kt) of West Bank and Gaza in 1999 to that in 2003?
Make the answer very short. 0.51. What is the ratio of the Emissions(kt) of Bermuda in 1999 to that in 2004?
Your response must be concise. 0.74. What is the ratio of the Emissions(kt) in Samoa in 1999 to that in 2004?
Give a very brief answer. 0.86. What is the ratio of the Emissions(kt) of St. Vincent and the Grenadines in 1999 to that in 2004?
Offer a very short reply. 0.75. What is the ratio of the Emissions(kt) in West Bank and Gaza in 1999 to that in 2004?
Make the answer very short. 0.35. What is the ratio of the Emissions(kt) of Bermuda in 2000 to that in 2001?
Keep it short and to the point. 1. What is the ratio of the Emissions(kt) in Samoa in 2000 to that in 2001?
Make the answer very short. 0.97. What is the ratio of the Emissions(kt) of St. Vincent and the Grenadines in 2000 to that in 2001?
Your answer should be very brief. 0.82. What is the ratio of the Emissions(kt) in West Bank and Gaza in 2000 to that in 2001?
Your response must be concise. 0.59. What is the ratio of the Emissions(kt) in Bermuda in 2000 to that in 2002?
Offer a terse response. 0.94. What is the ratio of the Emissions(kt) in Samoa in 2000 to that in 2002?
Provide a succinct answer. 0.97. What is the ratio of the Emissions(kt) in St. Vincent and the Grenadines in 2000 to that in 2002?
Make the answer very short. 0.78. What is the ratio of the Emissions(kt) in West Bank and Gaza in 2000 to that in 2002?
Provide a short and direct response. 0.69. What is the ratio of the Emissions(kt) in Bermuda in 2000 to that in 2003?
Ensure brevity in your answer.  0.97. What is the ratio of the Emissions(kt) in Samoa in 2000 to that in 2003?
Make the answer very short. 0.93. What is the ratio of the Emissions(kt) in St. Vincent and the Grenadines in 2000 to that in 2003?
Offer a terse response. 0.74. What is the ratio of the Emissions(kt) of West Bank and Gaza in 2000 to that in 2003?
Offer a very short reply. 0.62. What is the ratio of the Emissions(kt) in Bermuda in 2000 to that in 2004?
Your response must be concise. 0.74. What is the ratio of the Emissions(kt) in Samoa in 2000 to that in 2004?
Provide a short and direct response. 0.86. What is the ratio of the Emissions(kt) of West Bank and Gaza in 2000 to that in 2004?
Give a very brief answer. 0.42. What is the ratio of the Emissions(kt) in Bermuda in 2001 to that in 2002?
Provide a succinct answer. 0.94. What is the ratio of the Emissions(kt) of St. Vincent and the Grenadines in 2001 to that in 2002?
Offer a very short reply. 0.96. What is the ratio of the Emissions(kt) of West Bank and Gaza in 2001 to that in 2002?
Ensure brevity in your answer.  1.17. What is the ratio of the Emissions(kt) of Bermuda in 2001 to that in 2003?
Your response must be concise. 0.97. What is the ratio of the Emissions(kt) in Samoa in 2001 to that in 2003?
Provide a succinct answer. 0.95. What is the ratio of the Emissions(kt) in St. Vincent and the Grenadines in 2001 to that in 2003?
Your answer should be compact. 0.91. What is the ratio of the Emissions(kt) of West Bank and Gaza in 2001 to that in 2003?
Make the answer very short. 1.05. What is the ratio of the Emissions(kt) in Bermuda in 2001 to that in 2004?
Your response must be concise. 0.74. What is the ratio of the Emissions(kt) of Samoa in 2001 to that in 2004?
Give a very brief answer. 0.89. What is the ratio of the Emissions(kt) of St. Vincent and the Grenadines in 2001 to that in 2004?
Provide a succinct answer. 0.82. What is the ratio of the Emissions(kt) in West Bank and Gaza in 2001 to that in 2004?
Provide a succinct answer. 0.72. What is the ratio of the Emissions(kt) of Bermuda in 2002 to that in 2003?
Make the answer very short. 1.03. What is the ratio of the Emissions(kt) in Samoa in 2002 to that in 2003?
Provide a short and direct response. 0.95. What is the ratio of the Emissions(kt) in West Bank and Gaza in 2002 to that in 2003?
Provide a succinct answer. 0.9. What is the ratio of the Emissions(kt) in Bermuda in 2002 to that in 2004?
Your answer should be very brief. 0.78. What is the ratio of the Emissions(kt) in Samoa in 2002 to that in 2004?
Your response must be concise. 0.89. What is the ratio of the Emissions(kt) of West Bank and Gaza in 2002 to that in 2004?
Provide a short and direct response. 0.62. What is the ratio of the Emissions(kt) in Bermuda in 2003 to that in 2004?
Give a very brief answer. 0.76. What is the ratio of the Emissions(kt) of Samoa in 2003 to that in 2004?
Make the answer very short. 0.93. What is the ratio of the Emissions(kt) in West Bank and Gaza in 2003 to that in 2004?
Make the answer very short. 0.69. What is the difference between the highest and the second highest Emissions(kt) of Bermuda?
Offer a terse response. 146.68. What is the difference between the highest and the second highest Emissions(kt) in Samoa?
Ensure brevity in your answer.  11. What is the difference between the highest and the second highest Emissions(kt) in St. Vincent and the Grenadines?
Offer a terse response. 22. What is the difference between the highest and the second highest Emissions(kt) in West Bank and Gaza?
Offer a very short reply. 517.05. What is the difference between the highest and the lowest Emissions(kt) of Bermuda?
Provide a short and direct response. 209.02. What is the difference between the highest and the lowest Emissions(kt) in Samoa?
Your answer should be very brief. 29.34. What is the difference between the highest and the lowest Emissions(kt) in St. Vincent and the Grenadines?
Ensure brevity in your answer.  88.01. What is the difference between the highest and the lowest Emissions(kt) of West Bank and Gaza?
Ensure brevity in your answer.  1470.47. 